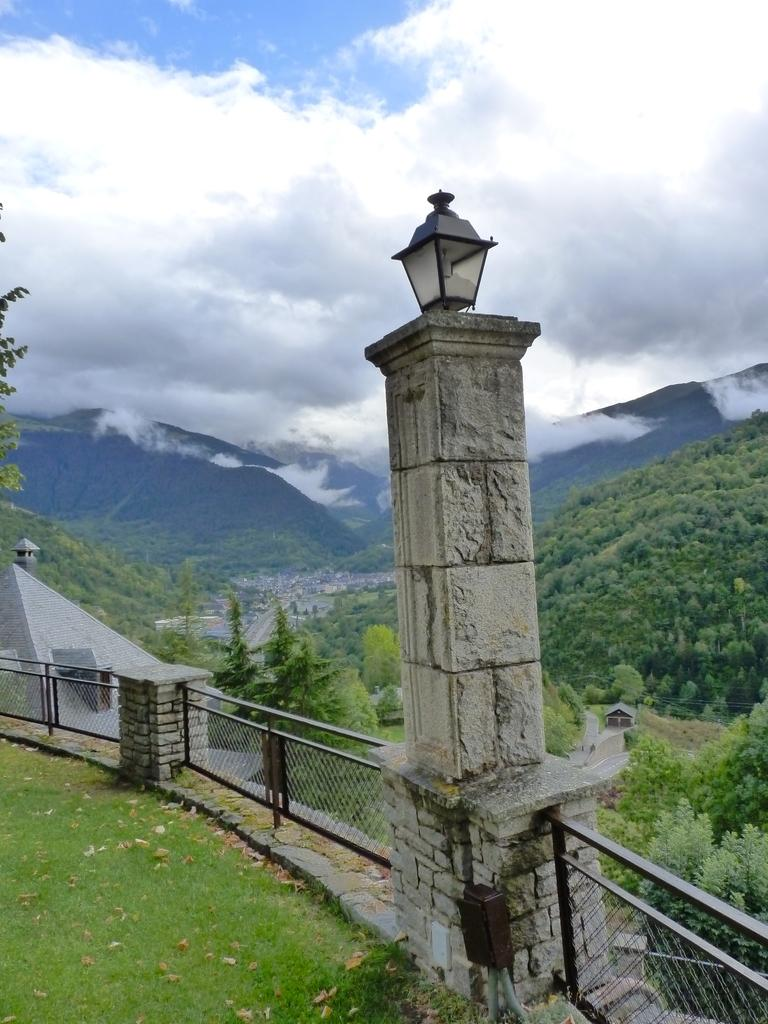What is the main structure in the image? There is a stone pillar in the image. What is attached to the stone pillar? A light is present on the stone pillar. What type of barrier can be seen in the image? There is a fence in the image. What type of vegetation is visible in the image? Grass and trees are present in the image. What type of landscape feature can be seen in the image? Hills are visible in the image. What is visible in the sky in the image? The sky is visible in the image, and clouds are present in the sky. How many chairs are present in the image? There are no chairs present in the image. 